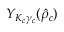<formula> <loc_0><loc_0><loc_500><loc_500>Y _ { K _ { c } \gamma _ { c } } ( \hat { \rho } _ { c } )</formula> 